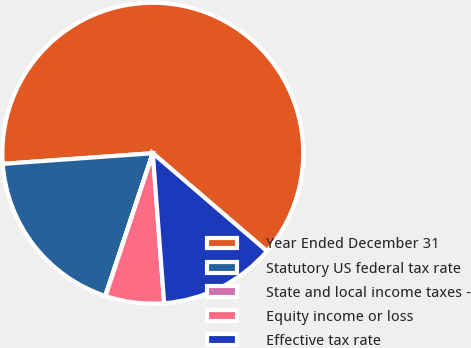<chart> <loc_0><loc_0><loc_500><loc_500><pie_chart><fcel>Year Ended December 31<fcel>Statutory US federal tax rate<fcel>State and local income taxes -<fcel>Equity income or loss<fcel>Effective tax rate<nl><fcel>62.42%<fcel>18.75%<fcel>0.04%<fcel>6.28%<fcel>12.51%<nl></chart> 